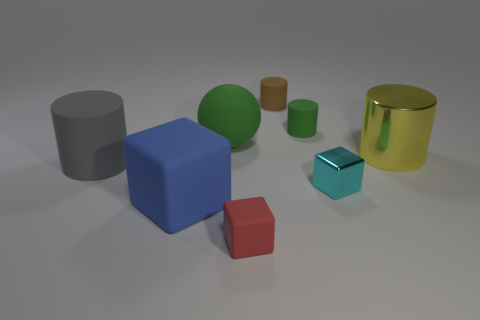Add 1 big yellow shiny balls. How many objects exist? 9 Subtract all spheres. How many objects are left? 7 Add 2 small matte cylinders. How many small matte cylinders are left? 4 Add 1 tiny cylinders. How many tiny cylinders exist? 3 Subtract 0 cyan cylinders. How many objects are left? 8 Subtract all yellow metallic cylinders. Subtract all green rubber cylinders. How many objects are left? 6 